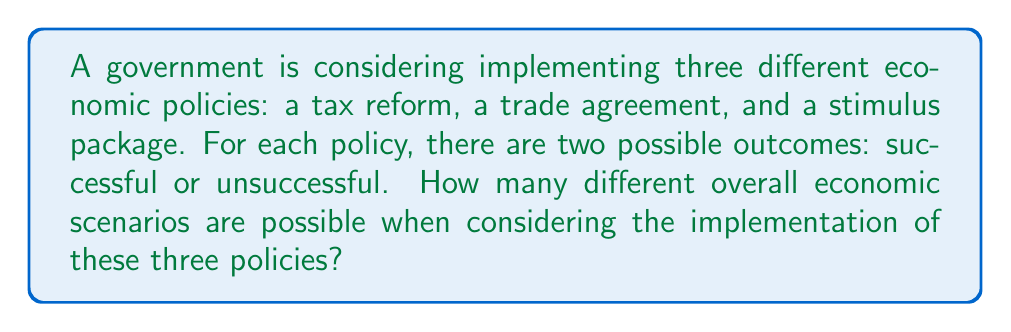Help me with this question. Let's approach this step-by-step:

1) We have three policies, and each policy has two possible outcomes.

2) This scenario can be modeled using the multiplication principle of counting.

3) For each policy:
   - Tax reform: 2 possibilities (successful or unsuccessful)
   - Trade agreement: 2 possibilities (successful or unsuccessful)
   - Stimulus package: 2 possibilities (successful or unsuccessful)

4) To find the total number of possible scenarios, we multiply the number of possibilities for each policy:

   $$ 2 \times 2 \times 2 = 2^3 = 8 $$

5) We can also think of this as a binary string of length 3, where each digit represents a policy (1 for success, 0 for failure). For example:
   - 000: all policies unsuccessful
   - 001: only stimulus package successful
   - 010: only trade agreement successful
   - 011: trade agreement and stimulus package successful
   - 100: only tax reform successful
   - 101: tax reform and stimulus package successful
   - 110: tax reform and trade agreement successful
   - 111: all policies successful

6) The number of such binary strings of length 3 is indeed $2^3 = 8$.

Therefore, there are 8 different possible overall economic scenarios.
Answer: 8 scenarios 